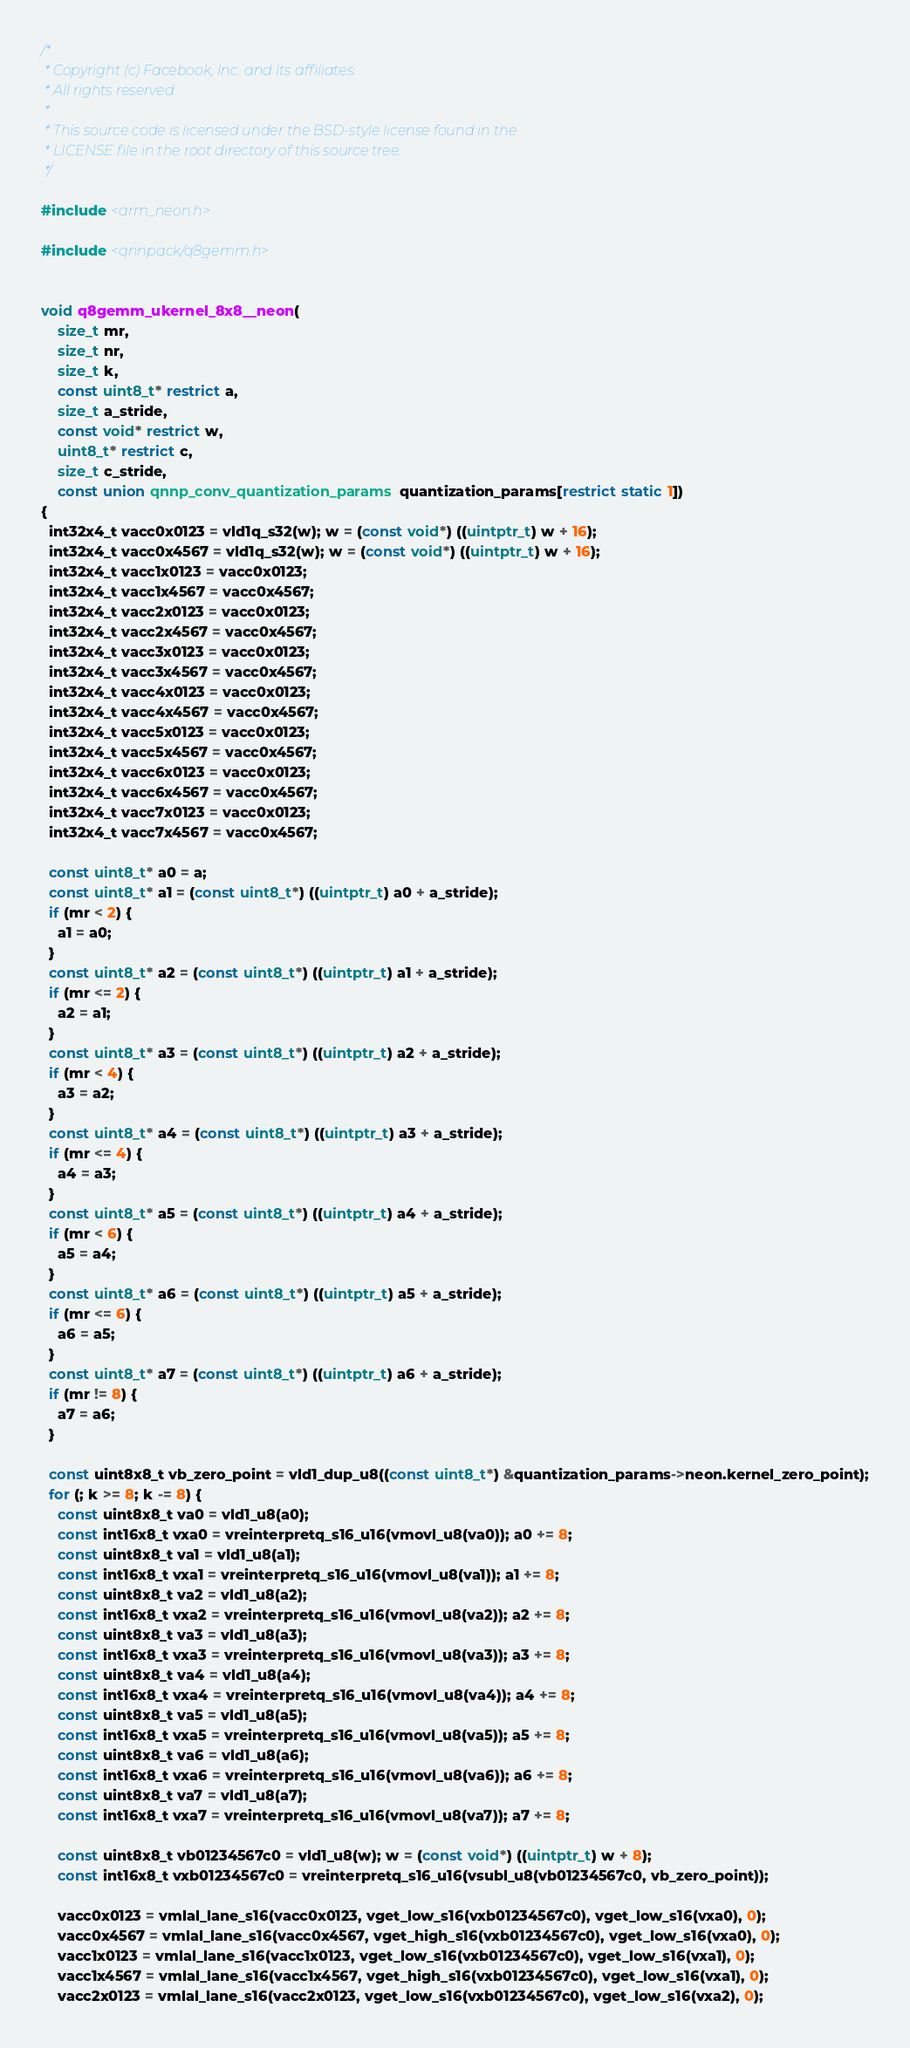<code> <loc_0><loc_0><loc_500><loc_500><_C_>/*
 * Copyright (c) Facebook, Inc. and its affiliates.
 * All rights reserved.
 *
 * This source code is licensed under the BSD-style license found in the
 * LICENSE file in the root directory of this source tree.
 */

#include <arm_neon.h>

#include <qnnpack/q8gemm.h>


void q8gemm_ukernel_8x8__neon(
    size_t mr,
    size_t nr,
    size_t k,
    const uint8_t* restrict a,
    size_t a_stride,
    const void* restrict w,
    uint8_t* restrict c,
    size_t c_stride,
    const union qnnp_conv_quantization_params quantization_params[restrict static 1])
{
  int32x4_t vacc0x0123 = vld1q_s32(w); w = (const void*) ((uintptr_t) w + 16);
  int32x4_t vacc0x4567 = vld1q_s32(w); w = (const void*) ((uintptr_t) w + 16);
  int32x4_t vacc1x0123 = vacc0x0123;
  int32x4_t vacc1x4567 = vacc0x4567;
  int32x4_t vacc2x0123 = vacc0x0123;
  int32x4_t vacc2x4567 = vacc0x4567;
  int32x4_t vacc3x0123 = vacc0x0123;
  int32x4_t vacc3x4567 = vacc0x4567;
  int32x4_t vacc4x0123 = vacc0x0123;
  int32x4_t vacc4x4567 = vacc0x4567;
  int32x4_t vacc5x0123 = vacc0x0123;
  int32x4_t vacc5x4567 = vacc0x4567;
  int32x4_t vacc6x0123 = vacc0x0123;
  int32x4_t vacc6x4567 = vacc0x4567;
  int32x4_t vacc7x0123 = vacc0x0123;
  int32x4_t vacc7x4567 = vacc0x4567;

  const uint8_t* a0 = a;
  const uint8_t* a1 = (const uint8_t*) ((uintptr_t) a0 + a_stride);
  if (mr < 2) {
    a1 = a0;
  }
  const uint8_t* a2 = (const uint8_t*) ((uintptr_t) a1 + a_stride);
  if (mr <= 2) {
    a2 = a1;
  }
  const uint8_t* a3 = (const uint8_t*) ((uintptr_t) a2 + a_stride);
  if (mr < 4) {
    a3 = a2;
  }
  const uint8_t* a4 = (const uint8_t*) ((uintptr_t) a3 + a_stride);
  if (mr <= 4) {
    a4 = a3;
  }
  const uint8_t* a5 = (const uint8_t*) ((uintptr_t) a4 + a_stride);
  if (mr < 6) {
    a5 = a4;
  }
  const uint8_t* a6 = (const uint8_t*) ((uintptr_t) a5 + a_stride);
  if (mr <= 6) {
    a6 = a5;
  }
  const uint8_t* a7 = (const uint8_t*) ((uintptr_t) a6 + a_stride);
  if (mr != 8) {
    a7 = a6;
  }

  const uint8x8_t vb_zero_point = vld1_dup_u8((const uint8_t*) &quantization_params->neon.kernel_zero_point);
  for (; k >= 8; k -= 8) {
    const uint8x8_t va0 = vld1_u8(a0);
    const int16x8_t vxa0 = vreinterpretq_s16_u16(vmovl_u8(va0)); a0 += 8;
    const uint8x8_t va1 = vld1_u8(a1);
    const int16x8_t vxa1 = vreinterpretq_s16_u16(vmovl_u8(va1)); a1 += 8;
    const uint8x8_t va2 = vld1_u8(a2);
    const int16x8_t vxa2 = vreinterpretq_s16_u16(vmovl_u8(va2)); a2 += 8;
    const uint8x8_t va3 = vld1_u8(a3);
    const int16x8_t vxa3 = vreinterpretq_s16_u16(vmovl_u8(va3)); a3 += 8;
    const uint8x8_t va4 = vld1_u8(a4);
    const int16x8_t vxa4 = vreinterpretq_s16_u16(vmovl_u8(va4)); a4 += 8;
    const uint8x8_t va5 = vld1_u8(a5);
    const int16x8_t vxa5 = vreinterpretq_s16_u16(vmovl_u8(va5)); a5 += 8;
    const uint8x8_t va6 = vld1_u8(a6);
    const int16x8_t vxa6 = vreinterpretq_s16_u16(vmovl_u8(va6)); a6 += 8;
    const uint8x8_t va7 = vld1_u8(a7);
    const int16x8_t vxa7 = vreinterpretq_s16_u16(vmovl_u8(va7)); a7 += 8;

    const uint8x8_t vb01234567c0 = vld1_u8(w); w = (const void*) ((uintptr_t) w + 8);
    const int16x8_t vxb01234567c0 = vreinterpretq_s16_u16(vsubl_u8(vb01234567c0, vb_zero_point));

    vacc0x0123 = vmlal_lane_s16(vacc0x0123, vget_low_s16(vxb01234567c0), vget_low_s16(vxa0), 0);
    vacc0x4567 = vmlal_lane_s16(vacc0x4567, vget_high_s16(vxb01234567c0), vget_low_s16(vxa0), 0);
    vacc1x0123 = vmlal_lane_s16(vacc1x0123, vget_low_s16(vxb01234567c0), vget_low_s16(vxa1), 0);
    vacc1x4567 = vmlal_lane_s16(vacc1x4567, vget_high_s16(vxb01234567c0), vget_low_s16(vxa1), 0);
    vacc2x0123 = vmlal_lane_s16(vacc2x0123, vget_low_s16(vxb01234567c0), vget_low_s16(vxa2), 0);</code> 